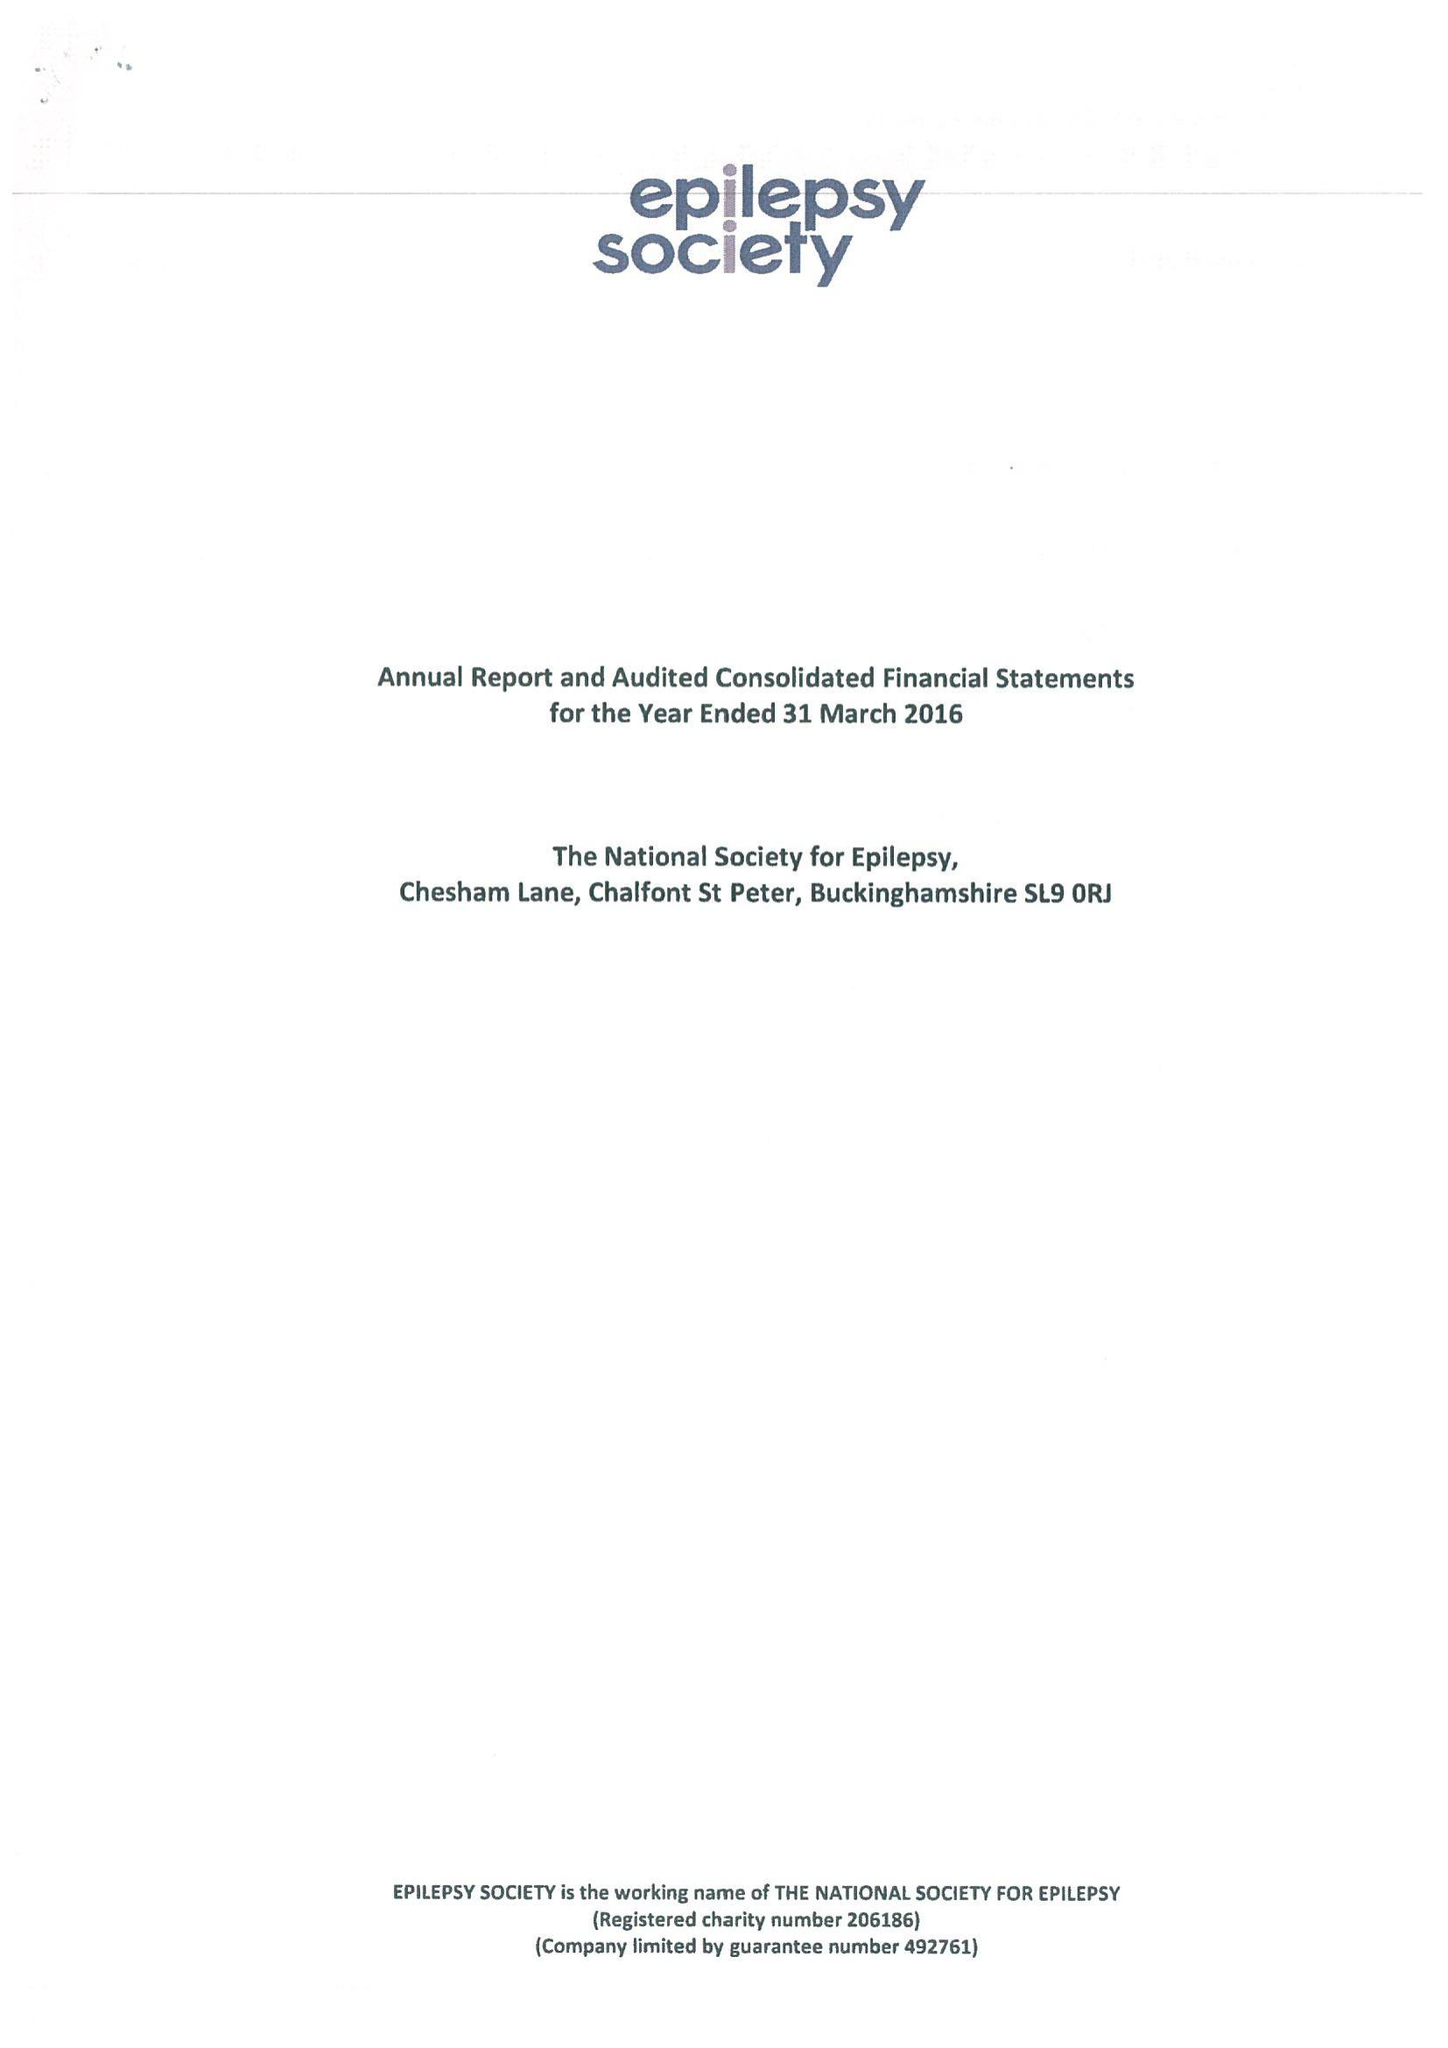What is the value for the charity_number?
Answer the question using a single word or phrase. 206186 